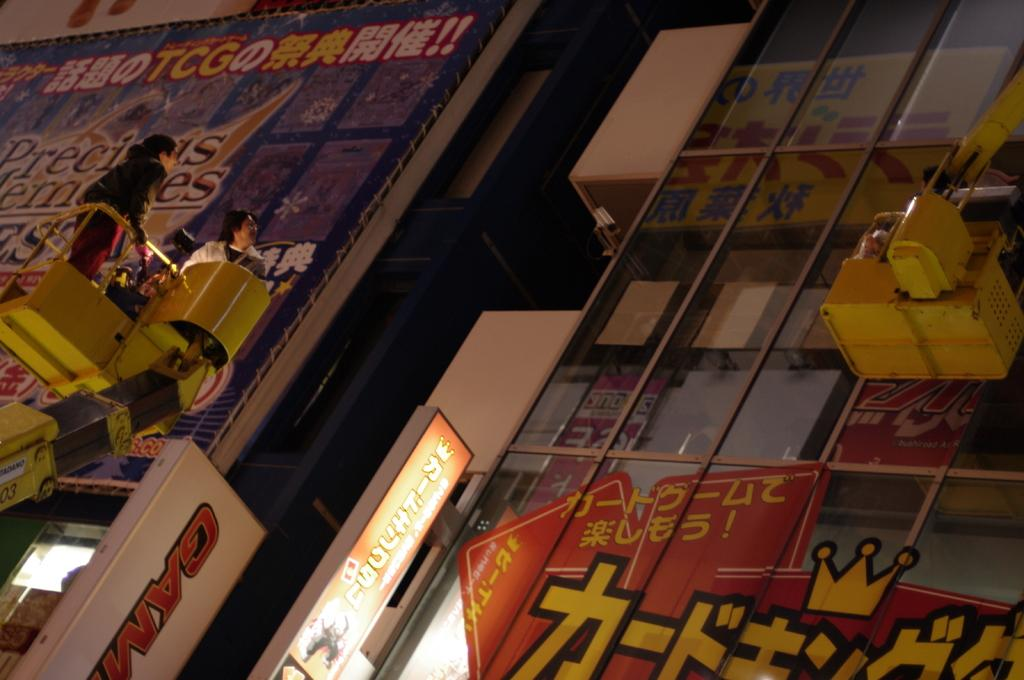<image>
Present a compact description of the photo's key features. A window featuring Asian writing and Gam in the bottbom. 